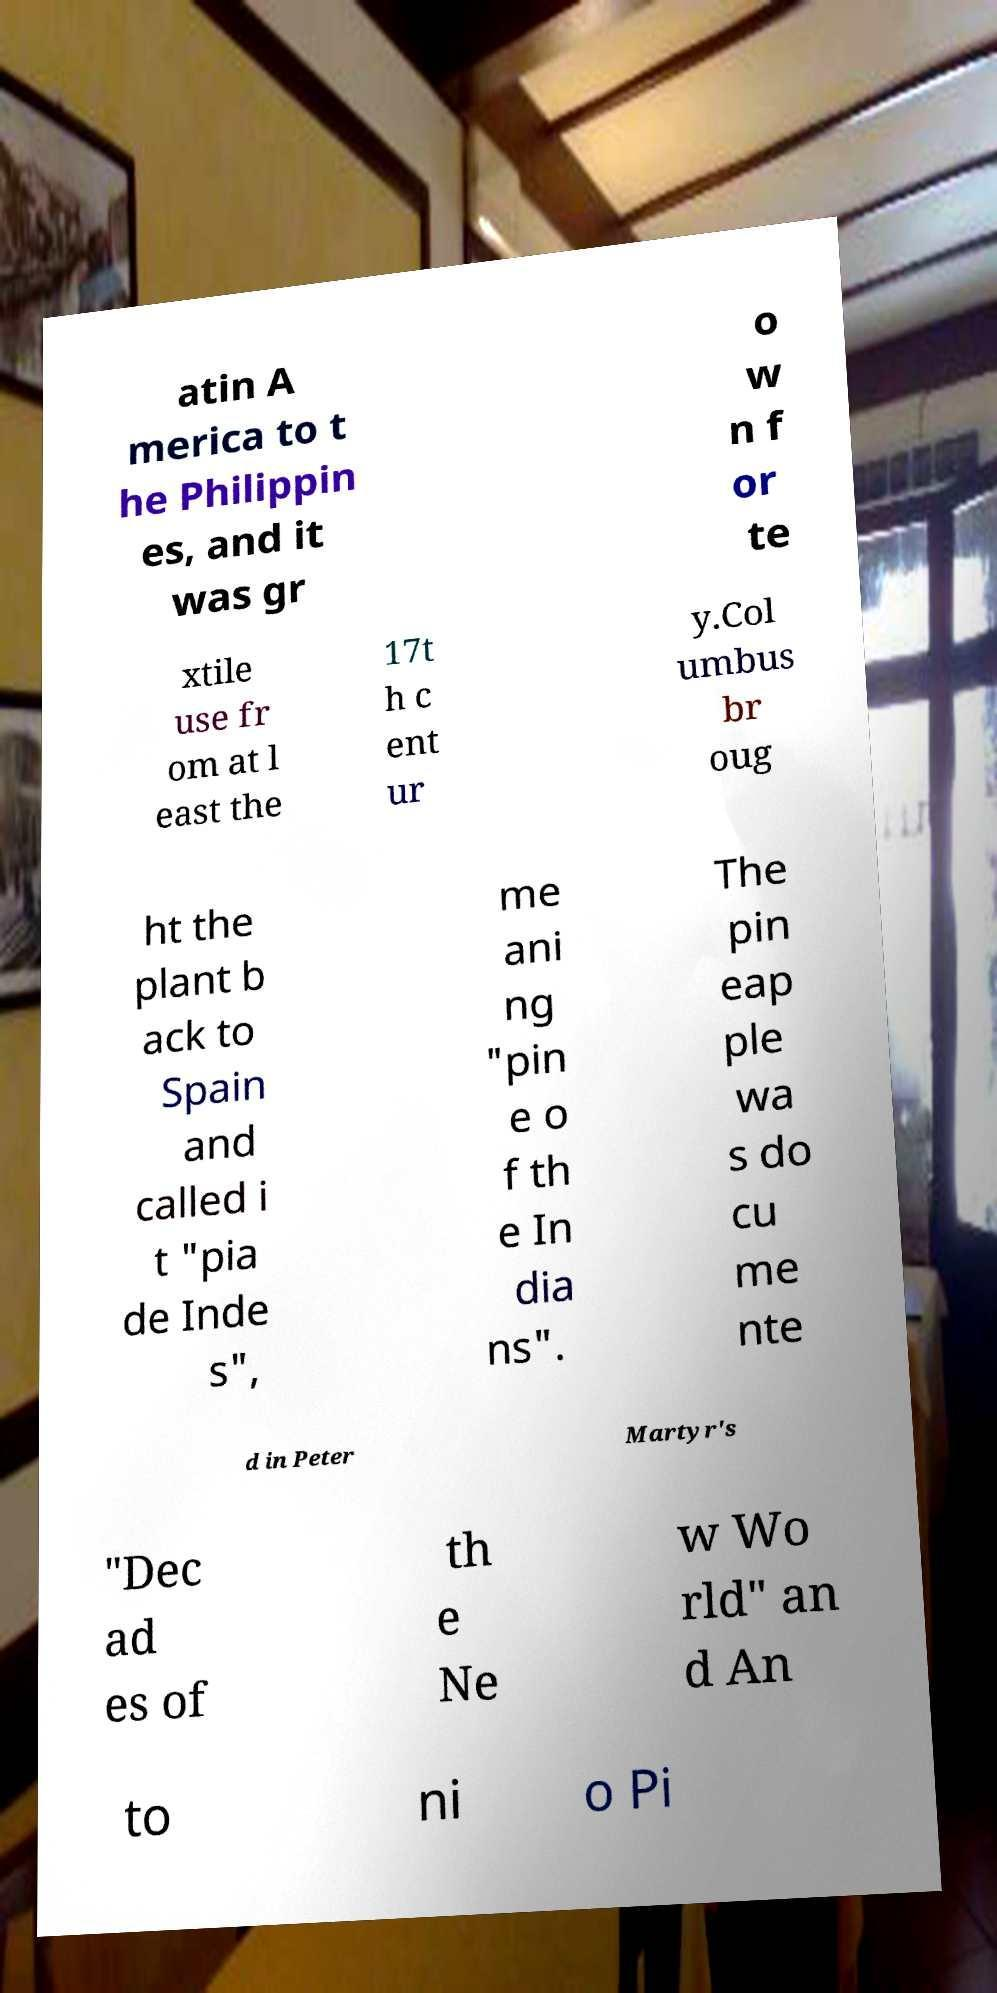Please read and relay the text visible in this image. What does it say? atin A merica to t he Philippin es, and it was gr o w n f or te xtile use fr om at l east the 17t h c ent ur y.Col umbus br oug ht the plant b ack to Spain and called i t "pia de Inde s", me ani ng "pin e o f th e In dia ns". The pin eap ple wa s do cu me nte d in Peter Martyr's "Dec ad es of th e Ne w Wo rld" an d An to ni o Pi 